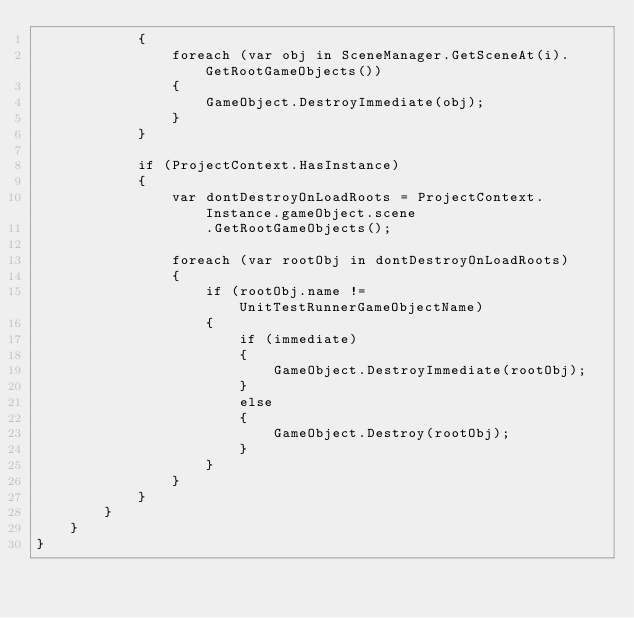<code> <loc_0><loc_0><loc_500><loc_500><_C#_>            {
                foreach (var obj in SceneManager.GetSceneAt(i).GetRootGameObjects())
                {
                    GameObject.DestroyImmediate(obj);
                }
            }

            if (ProjectContext.HasInstance)
            {
                var dontDestroyOnLoadRoots = ProjectContext.Instance.gameObject.scene
                    .GetRootGameObjects();

                foreach (var rootObj in dontDestroyOnLoadRoots)
                {
                    if (rootObj.name != UnitTestRunnerGameObjectName)
                    {
                        if (immediate)
                        {
                            GameObject.DestroyImmediate(rootObj);
                        }
                        else
                        {
                            GameObject.Destroy(rootObj);
                        }
                    }
                }
            }
        }
    }
}
</code> 